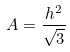<formula> <loc_0><loc_0><loc_500><loc_500>A = \frac { h ^ { 2 } } { \sqrt { 3 } }</formula> 